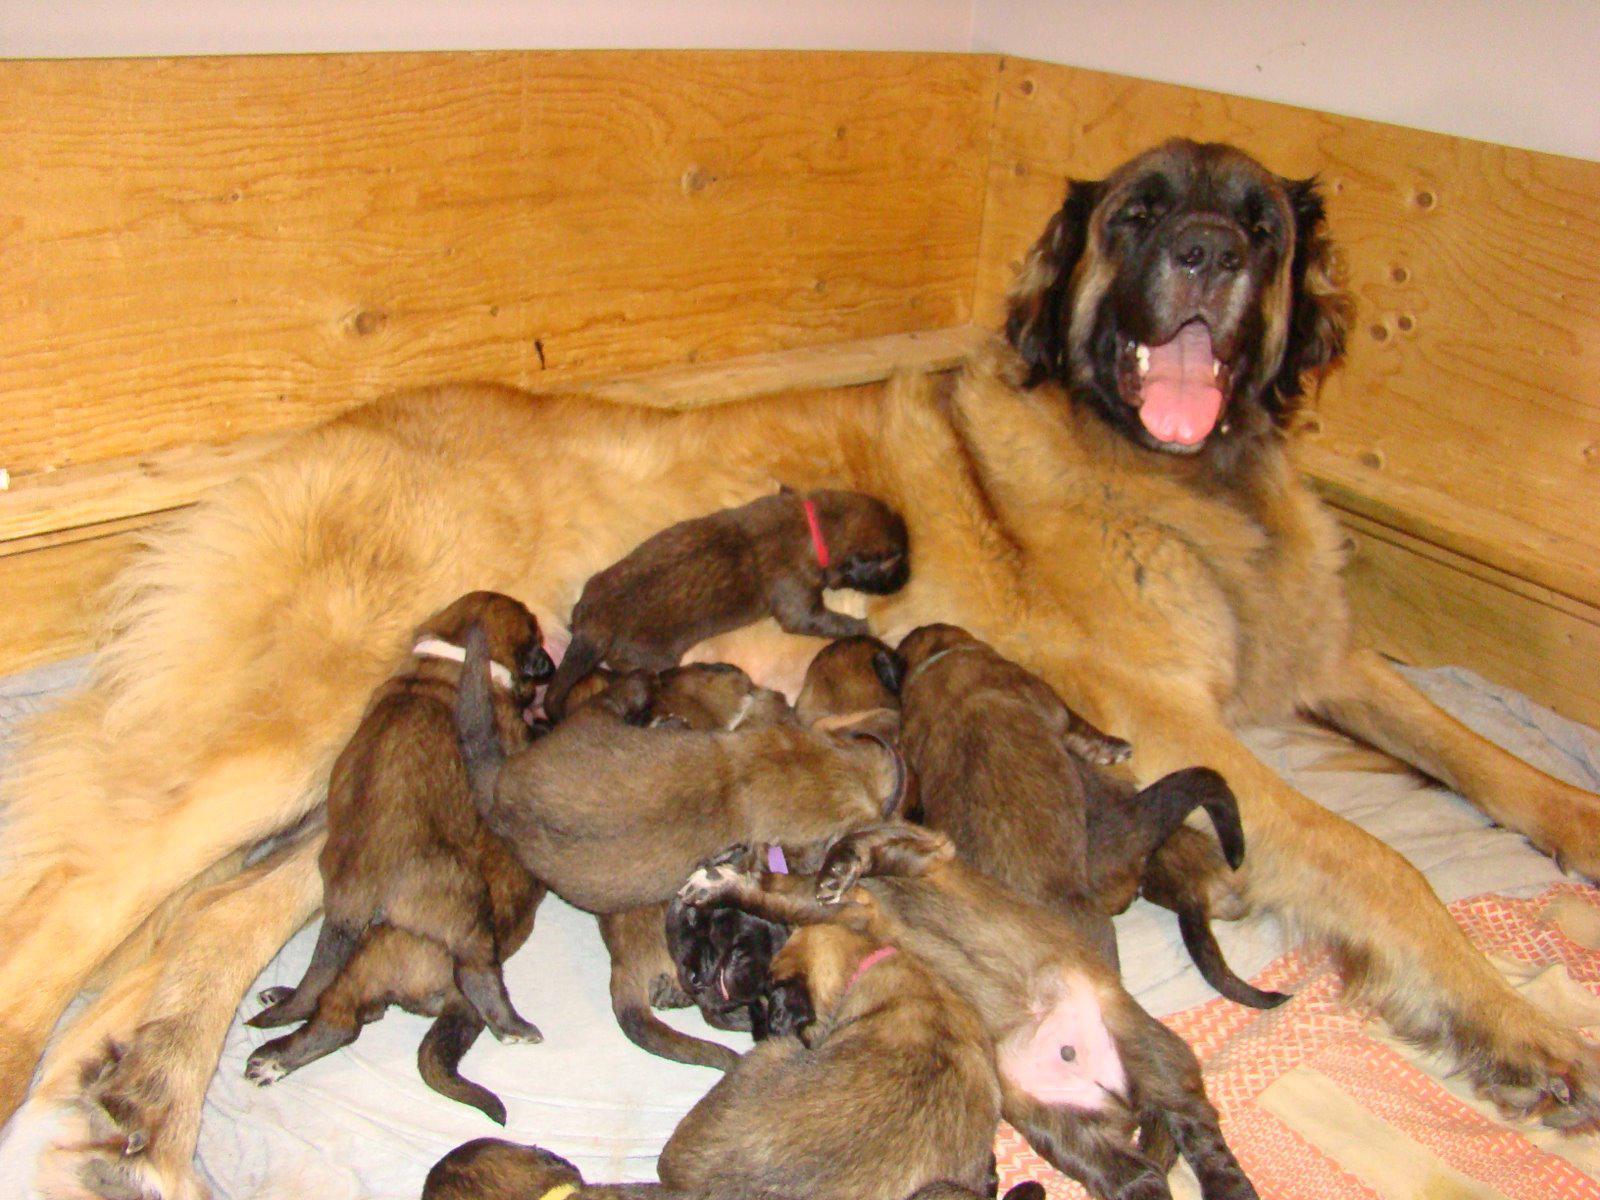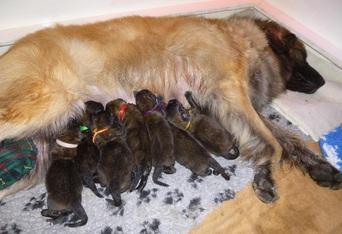The first image is the image on the left, the second image is the image on the right. Evaluate the accuracy of this statement regarding the images: "Right image shows a mother dog with raised head and her pups, surrounded by a natural wood border.". Is it true? Answer yes or no. No. The first image is the image on the left, the second image is the image on the right. Given the left and right images, does the statement "The dog in the image on the right is nursing in an area surrounded by wooden planks." hold true? Answer yes or no. No. 